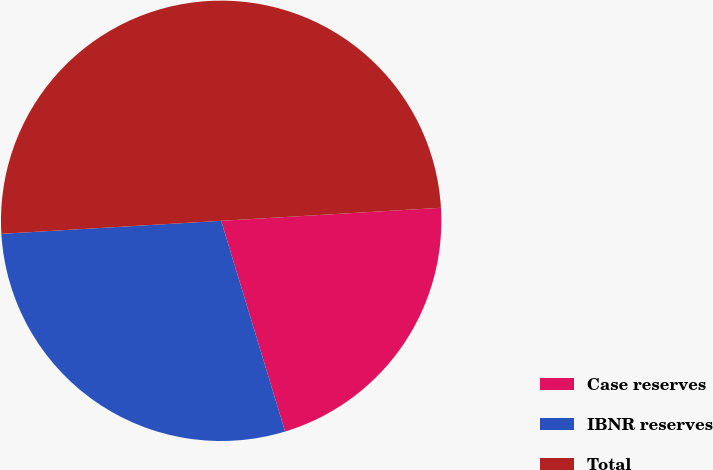Convert chart to OTSL. <chart><loc_0><loc_0><loc_500><loc_500><pie_chart><fcel>Case reserves<fcel>IBNR reserves<fcel>Total<nl><fcel>21.25%<fcel>28.75%<fcel>50.0%<nl></chart> 